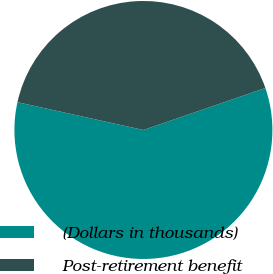Convert chart to OTSL. <chart><loc_0><loc_0><loc_500><loc_500><pie_chart><fcel>(Dollars in thousands)<fcel>Post-retirement benefit<nl><fcel>58.73%<fcel>41.27%<nl></chart> 